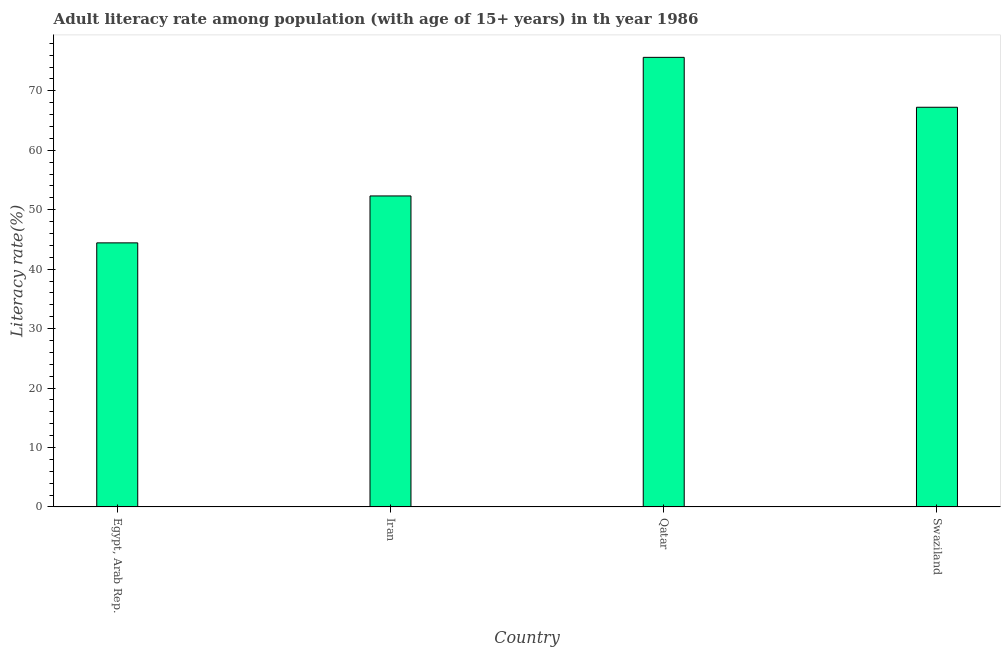Does the graph contain grids?
Keep it short and to the point. No. What is the title of the graph?
Your response must be concise. Adult literacy rate among population (with age of 15+ years) in th year 1986. What is the label or title of the Y-axis?
Your answer should be very brief. Literacy rate(%). What is the adult literacy rate in Iran?
Your response must be concise. 52.32. Across all countries, what is the maximum adult literacy rate?
Provide a short and direct response. 75.64. Across all countries, what is the minimum adult literacy rate?
Keep it short and to the point. 44.42. In which country was the adult literacy rate maximum?
Provide a succinct answer. Qatar. In which country was the adult literacy rate minimum?
Offer a very short reply. Egypt, Arab Rep. What is the sum of the adult literacy rate?
Ensure brevity in your answer.  239.62. What is the difference between the adult literacy rate in Qatar and Swaziland?
Provide a succinct answer. 8.4. What is the average adult literacy rate per country?
Your answer should be very brief. 59.91. What is the median adult literacy rate?
Give a very brief answer. 59.78. What is the ratio of the adult literacy rate in Iran to that in Swaziland?
Give a very brief answer. 0.78. Is the difference between the adult literacy rate in Egypt, Arab Rep. and Iran greater than the difference between any two countries?
Make the answer very short. No. What is the difference between the highest and the second highest adult literacy rate?
Ensure brevity in your answer.  8.4. Is the sum of the adult literacy rate in Iran and Swaziland greater than the maximum adult literacy rate across all countries?
Provide a succinct answer. Yes. What is the difference between the highest and the lowest adult literacy rate?
Make the answer very short. 31.21. How many bars are there?
Ensure brevity in your answer.  4. Are all the bars in the graph horizontal?
Offer a terse response. No. What is the difference between two consecutive major ticks on the Y-axis?
Ensure brevity in your answer.  10. Are the values on the major ticks of Y-axis written in scientific E-notation?
Ensure brevity in your answer.  No. What is the Literacy rate(%) of Egypt, Arab Rep.?
Your response must be concise. 44.42. What is the Literacy rate(%) in Iran?
Your answer should be very brief. 52.32. What is the Literacy rate(%) of Qatar?
Ensure brevity in your answer.  75.64. What is the Literacy rate(%) of Swaziland?
Ensure brevity in your answer.  67.24. What is the difference between the Literacy rate(%) in Egypt, Arab Rep. and Iran?
Ensure brevity in your answer.  -7.9. What is the difference between the Literacy rate(%) in Egypt, Arab Rep. and Qatar?
Offer a terse response. -31.21. What is the difference between the Literacy rate(%) in Egypt, Arab Rep. and Swaziland?
Ensure brevity in your answer.  -22.82. What is the difference between the Literacy rate(%) in Iran and Qatar?
Provide a short and direct response. -23.32. What is the difference between the Literacy rate(%) in Iran and Swaziland?
Make the answer very short. -14.92. What is the difference between the Literacy rate(%) in Qatar and Swaziland?
Provide a short and direct response. 8.4. What is the ratio of the Literacy rate(%) in Egypt, Arab Rep. to that in Iran?
Ensure brevity in your answer.  0.85. What is the ratio of the Literacy rate(%) in Egypt, Arab Rep. to that in Qatar?
Your response must be concise. 0.59. What is the ratio of the Literacy rate(%) in Egypt, Arab Rep. to that in Swaziland?
Your answer should be compact. 0.66. What is the ratio of the Literacy rate(%) in Iran to that in Qatar?
Make the answer very short. 0.69. What is the ratio of the Literacy rate(%) in Iran to that in Swaziland?
Your response must be concise. 0.78. 